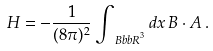Convert formula to latex. <formula><loc_0><loc_0><loc_500><loc_500>H = - \frac { 1 } { ( 8 \pi ) ^ { 2 } } \int _ { { \ B b b R } ^ { 3 } } d { x } \, { B \cdot A } \, .</formula> 